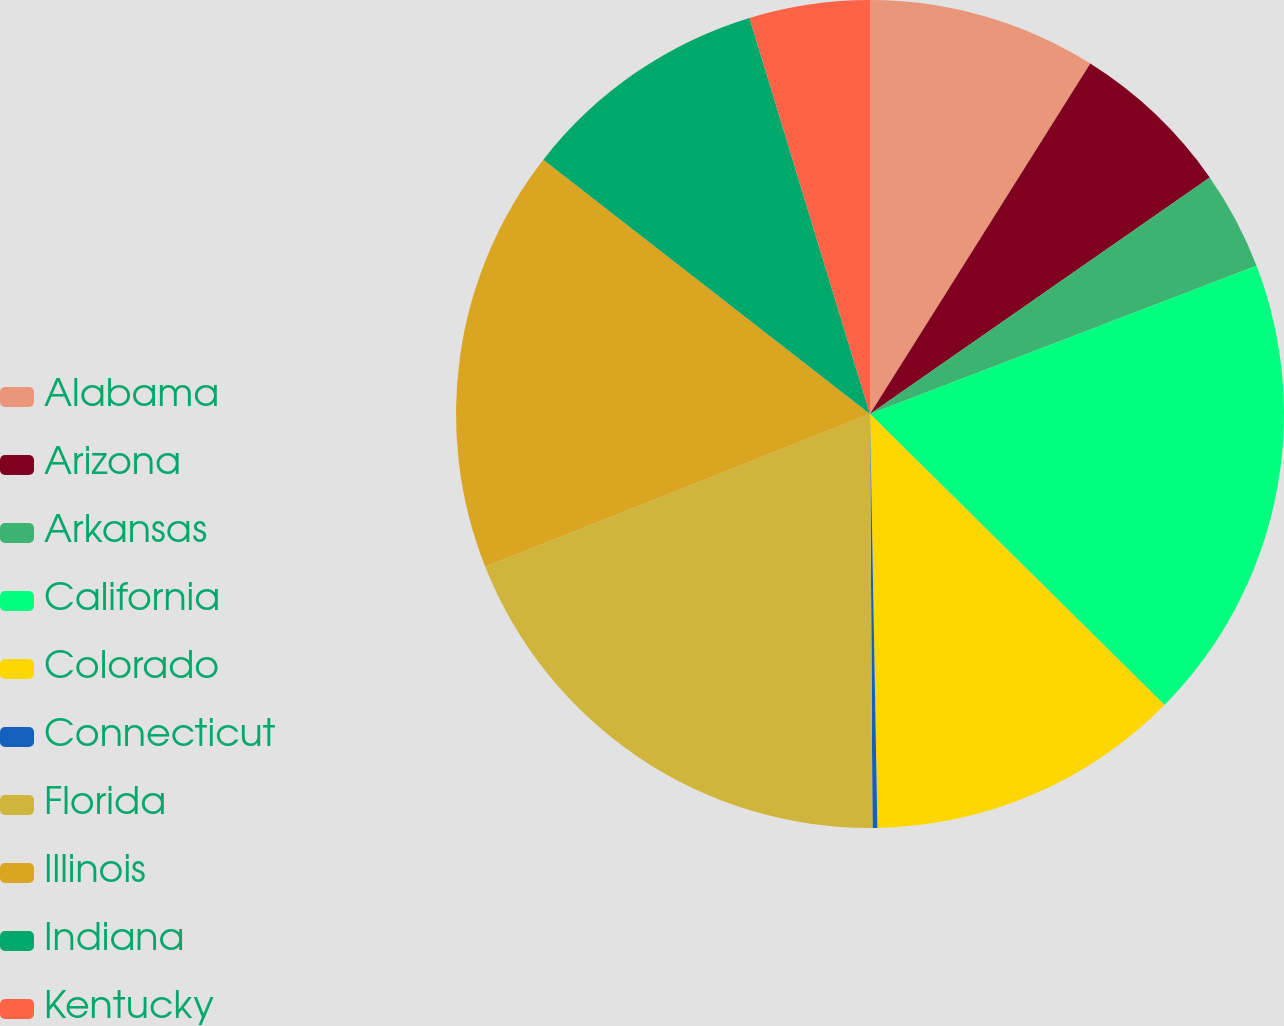<chart> <loc_0><loc_0><loc_500><loc_500><pie_chart><fcel>Alabama<fcel>Arizona<fcel>Arkansas<fcel>California<fcel>Colorado<fcel>Connecticut<fcel>Florida<fcel>Illinois<fcel>Indiana<fcel>Kentucky<nl><fcel>8.93%<fcel>6.39%<fcel>3.85%<fcel>18.23%<fcel>12.31%<fcel>0.19%<fcel>19.08%<fcel>16.54%<fcel>9.77%<fcel>4.7%<nl></chart> 